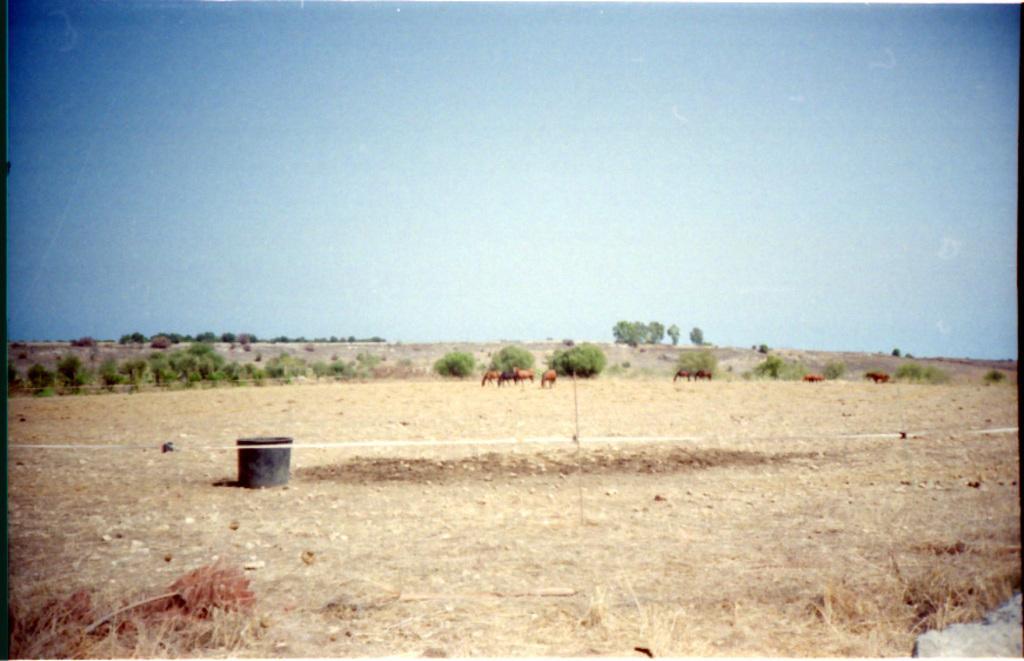In one or two sentences, can you explain what this image depicts? In this image there is a barren land. In the center there is a box on the ground. In the background there are a few animals and trees. At the top there is the sky. 